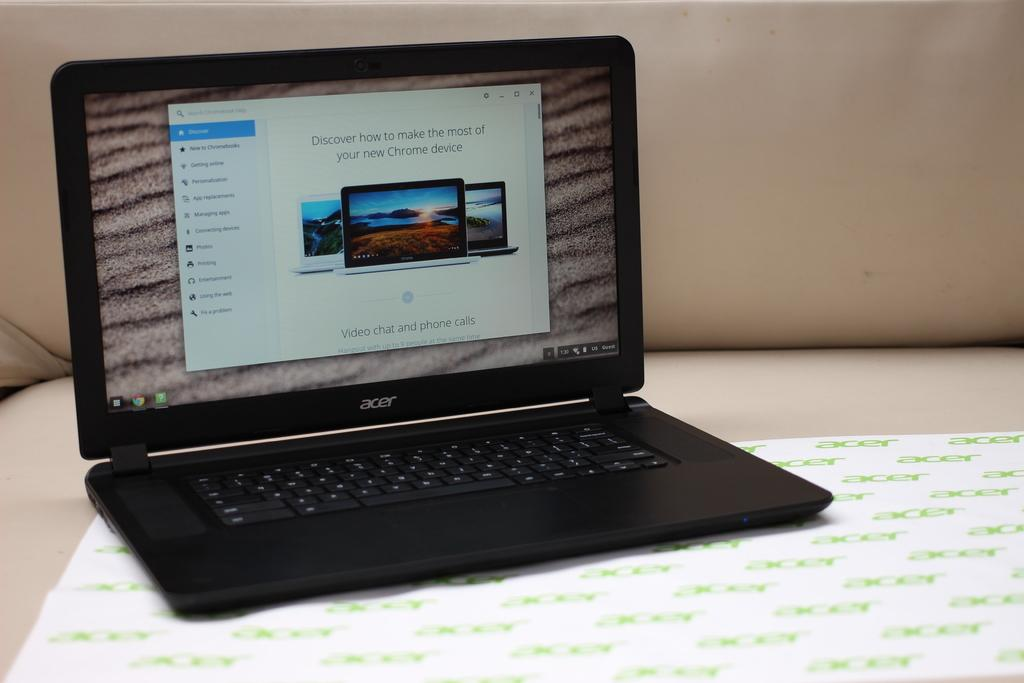<image>
Share a concise interpretation of the image provided. the word Chrome is on a laptop that is open 